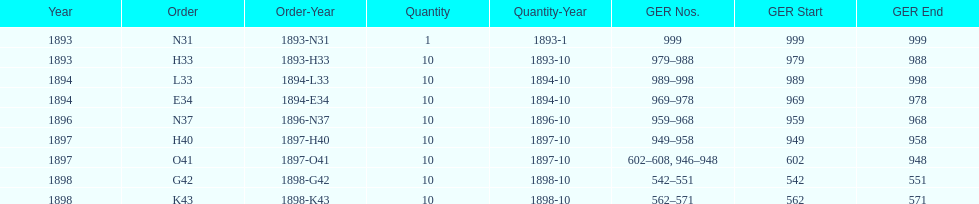What is the ultimate year displayed? 1898. 